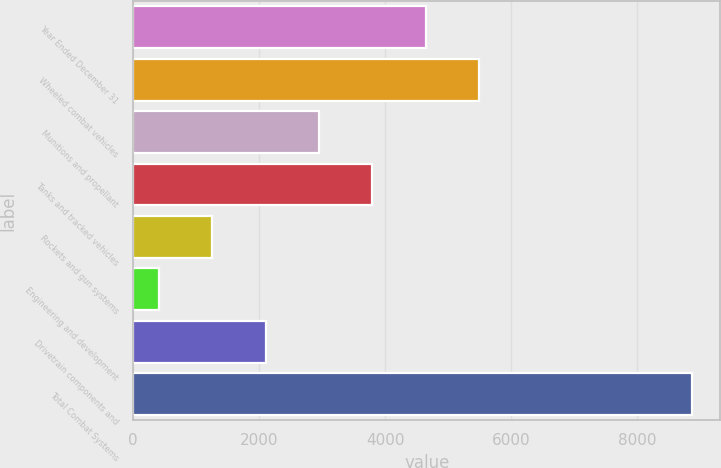<chart> <loc_0><loc_0><loc_500><loc_500><bar_chart><fcel>Year Ended December 31<fcel>Wheeled combat vehicles<fcel>Munitions and propellant<fcel>Tanks and tracked vehicles<fcel>Rockets and gun systems<fcel>Engineering and development<fcel>Drivetrain components and<fcel>Total Combat Systems<nl><fcel>4643<fcel>5490<fcel>2949<fcel>3796<fcel>1255<fcel>408<fcel>2102<fcel>8878<nl></chart> 